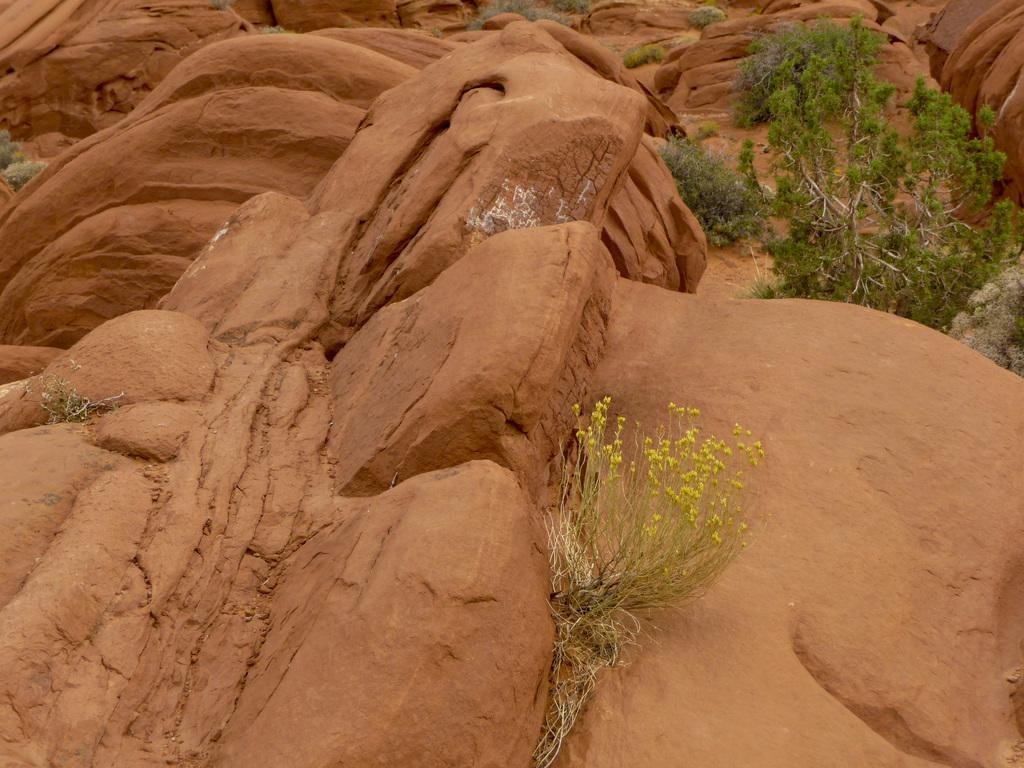What type of rocks can be seen in the image? There are brown color rocks in the image. What is located in the front of the image? There is a plant in the front of the image. What can be seen in the background of the image? There are more plants and a tree visible in the background of the image. What type of flame can be seen on the tree in the image? There is no flame present in the image; it features rocks, plants, and a tree. How many ladybugs are visible on the rocks in the image? There are no ladybugs present in the image; it only features rocks, plants, and a tree. 